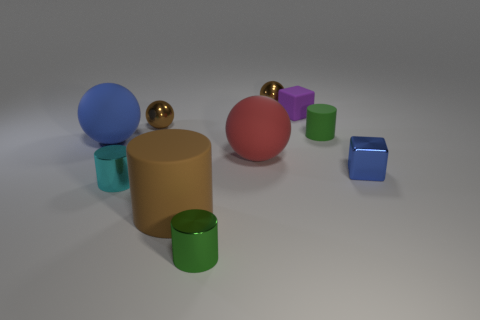What size is the cyan object that is to the left of the green shiny object?
Ensure brevity in your answer.  Small. Do the rubber block and the rubber sphere on the left side of the red rubber ball have the same size?
Your answer should be very brief. No. There is a rubber sphere that is on the right side of the big blue rubber ball; does it have the same size as the rubber cylinder that is in front of the big blue matte sphere?
Ensure brevity in your answer.  Yes. The tiny rubber block is what color?
Provide a succinct answer. Purple. There is a green thing to the left of the purple thing; is its shape the same as the tiny cyan thing?
Provide a succinct answer. Yes. What is the cyan cylinder made of?
Give a very brief answer. Metal. What shape is the brown thing that is the same size as the blue matte thing?
Your answer should be compact. Cylinder. Is there a matte cylinder that has the same color as the rubber cube?
Provide a succinct answer. No. Does the small rubber cylinder have the same color as the small metal cylinder that is in front of the big rubber cylinder?
Provide a succinct answer. Yes. The rubber cylinder on the left side of the brown object that is behind the small purple rubber cube is what color?
Provide a short and direct response. Brown. 